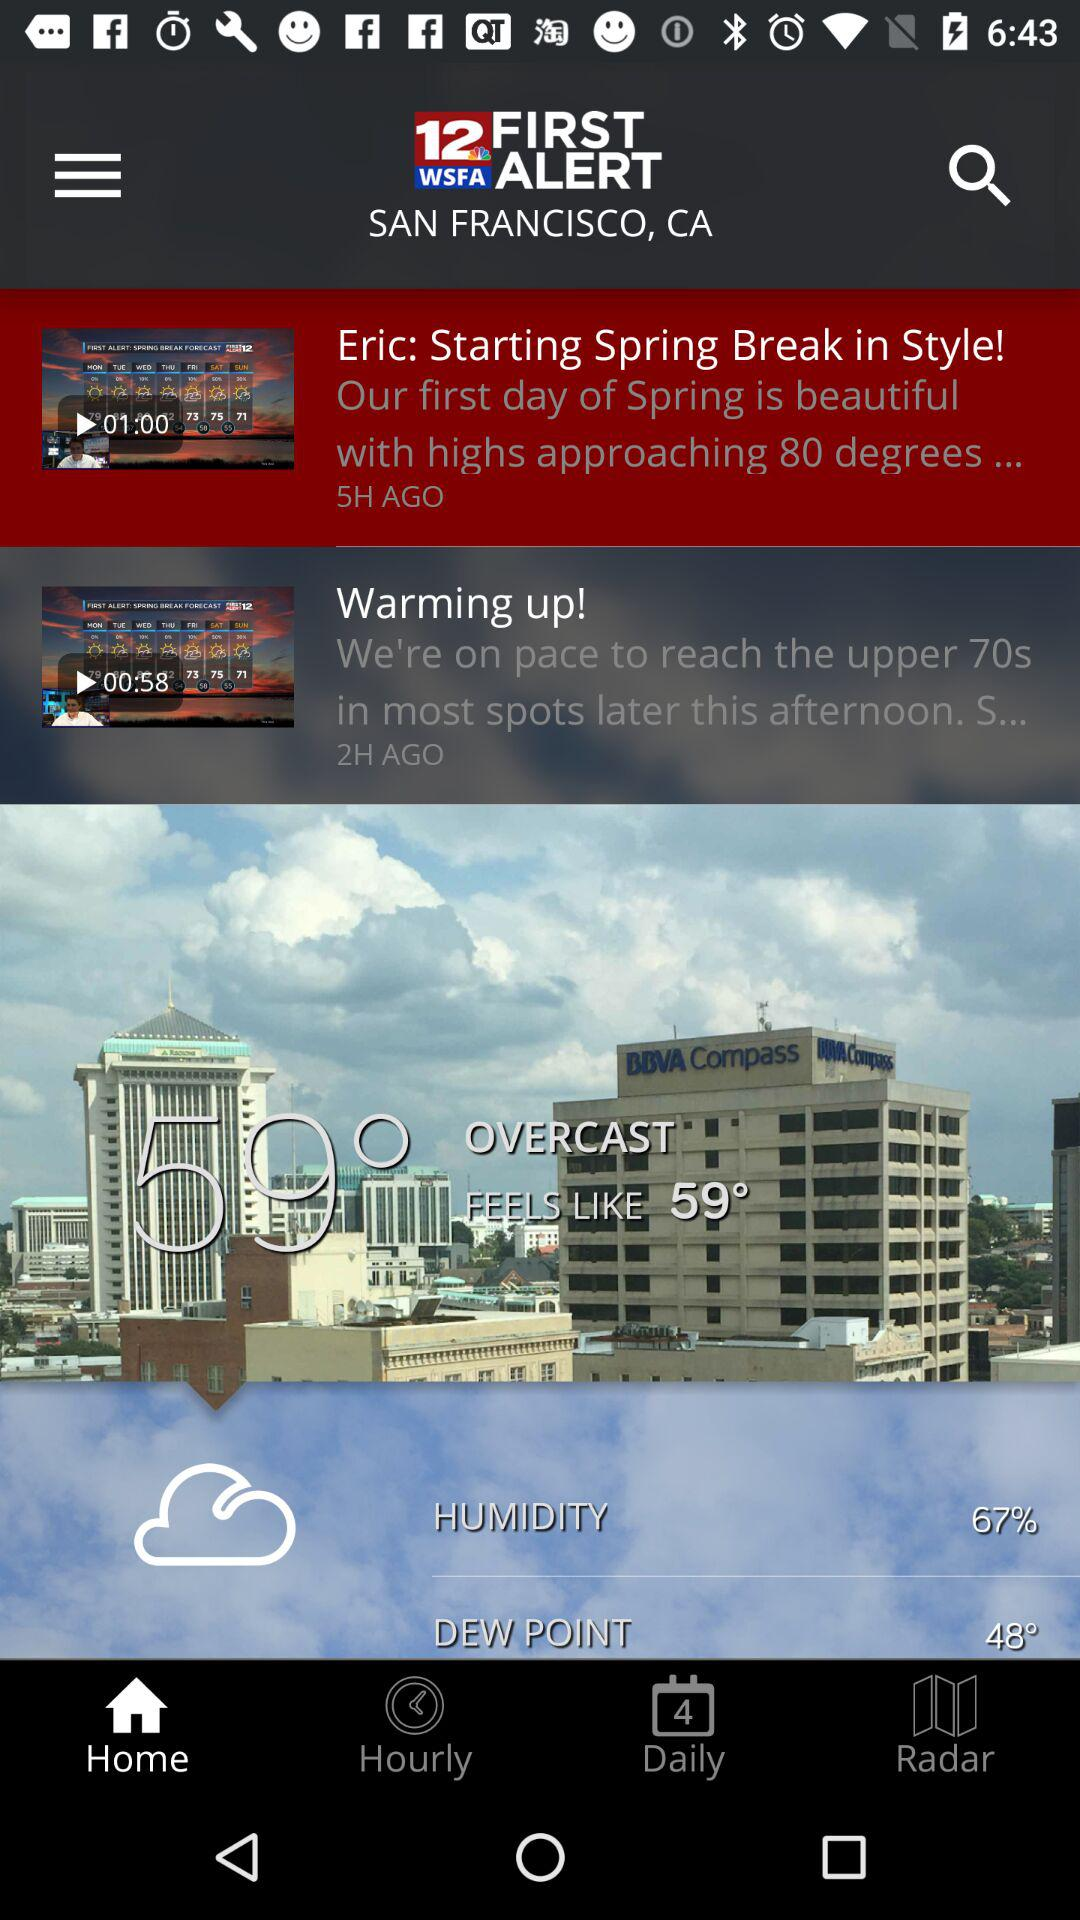How many hours ago was the first item posted?
Answer the question using a single word or phrase. 5 